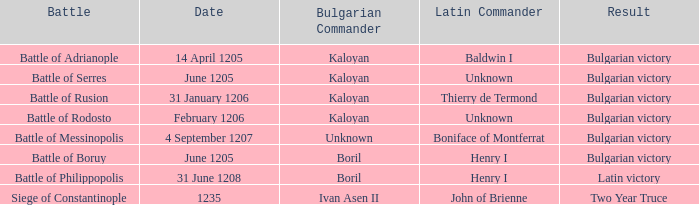Who is the bulgarian commander of the battle of rusion? Kaloyan. 